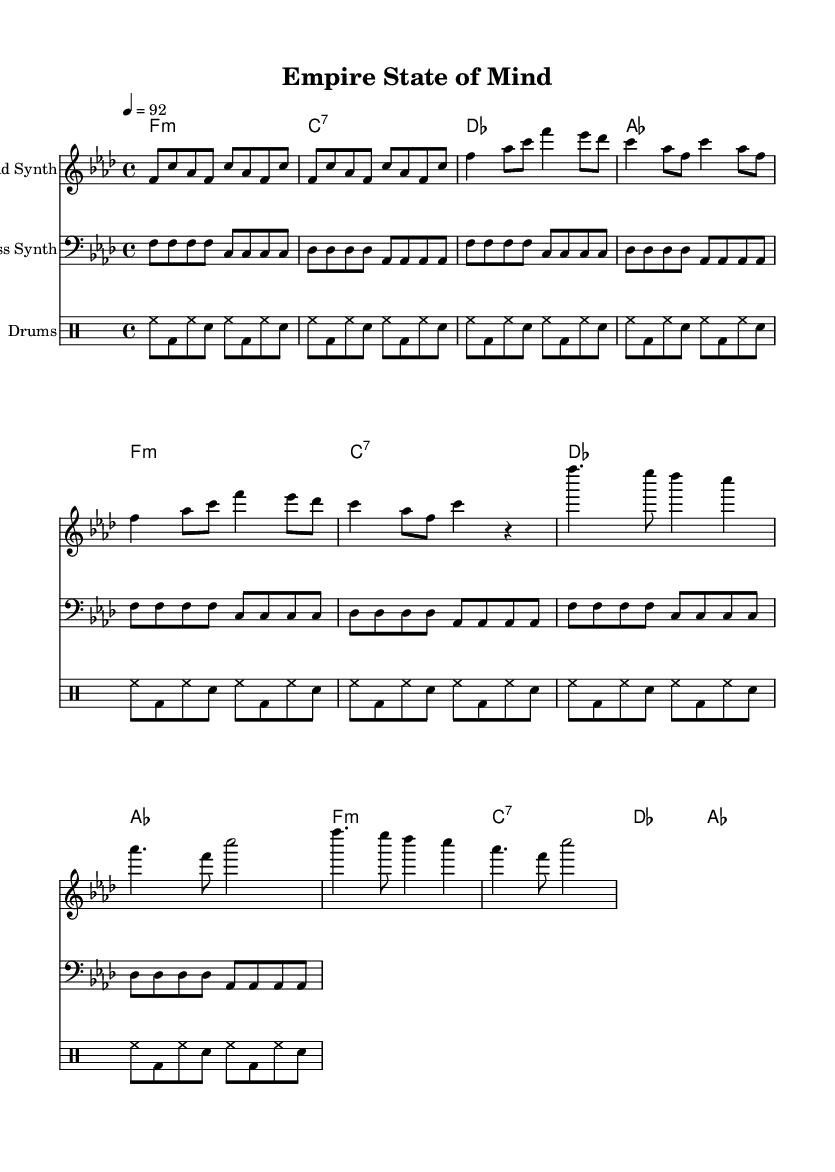What is the key signature of this music? The key signature is F minor, which has four flats (B♭, E♭, A♭, and D♭). This is indicated at the beginning of the staff where the flats are shown.
Answer: F minor What is the time signature of this music? The time signature is 4/4, meaning there are four beats in a measure, and the quarter note receives one beat. This is typically found at the beginning of the score.
Answer: 4/4 What is the tempo of this music? The tempo is marked as 92 beats per minute, indicated by the tempo marking at the beginning of the score.
Answer: 92 How many measures are in the verse section? The verse section consists of 4 measures, as counted in the melody line where the verse notes are grouped.
Answer: 4 What type of instruments are used in this score? The instruments listed are a Lead Synth, Bass Synth, and Drums, as denoted at the beginning of each staff.
Answer: Lead Synth, Bass Synth, Drums How many times is the intro repeated? The intro is repeated 2 times, as shown by the repeat sign which indicates a section should be played more than once.
Answer: 2 Which musical form is predominantly featured in this Hip Hop piece? The piece utilizes a verse-chorus form, typical of Hip Hop music, as it contains distinct sections for verses followed by a repeated chorus.
Answer: Verse-Chorus 